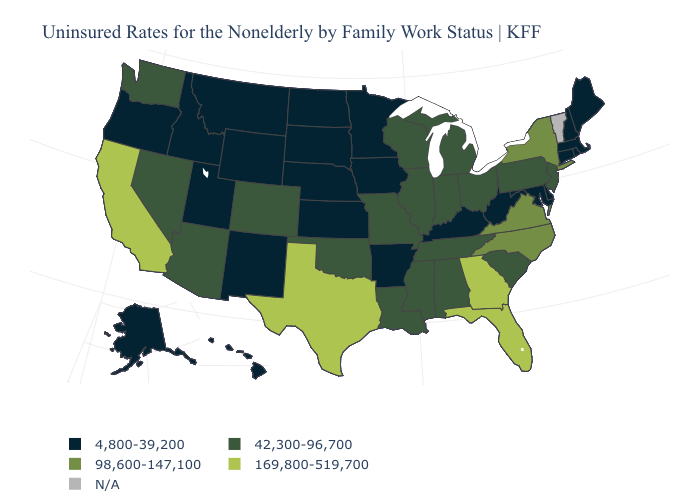Name the states that have a value in the range N/A?
Give a very brief answer. Vermont. What is the value of Michigan?
Write a very short answer. 42,300-96,700. Does Massachusetts have the lowest value in the Northeast?
Write a very short answer. Yes. Among the states that border Wisconsin , which have the lowest value?
Give a very brief answer. Iowa, Minnesota. Which states have the lowest value in the USA?
Short answer required. Alaska, Arkansas, Connecticut, Delaware, Hawaii, Idaho, Iowa, Kansas, Kentucky, Maine, Maryland, Massachusetts, Minnesota, Montana, Nebraska, New Hampshire, New Mexico, North Dakota, Oregon, Rhode Island, South Dakota, Utah, West Virginia, Wyoming. Among the states that border Virginia , does Kentucky have the highest value?
Be succinct. No. What is the value of South Dakota?
Quick response, please. 4,800-39,200. Does the first symbol in the legend represent the smallest category?
Write a very short answer. Yes. Which states hav the highest value in the Northeast?
Answer briefly. New York. Does Georgia have the lowest value in the South?
Keep it brief. No. What is the value of Oklahoma?
Short answer required. 42,300-96,700. What is the value of North Carolina?
Keep it brief. 98,600-147,100. What is the value of Alaska?
Be succinct. 4,800-39,200. Among the states that border Georgia , does North Carolina have the lowest value?
Answer briefly. No. Name the states that have a value in the range 42,300-96,700?
Concise answer only. Alabama, Arizona, Colorado, Illinois, Indiana, Louisiana, Michigan, Mississippi, Missouri, Nevada, New Jersey, Ohio, Oklahoma, Pennsylvania, South Carolina, Tennessee, Washington, Wisconsin. 